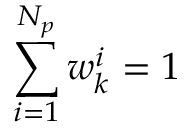Convert formula to latex. <formula><loc_0><loc_0><loc_500><loc_500>\sum _ { i = 1 } ^ { N _ { p } } w _ { k } ^ { i } = 1</formula> 